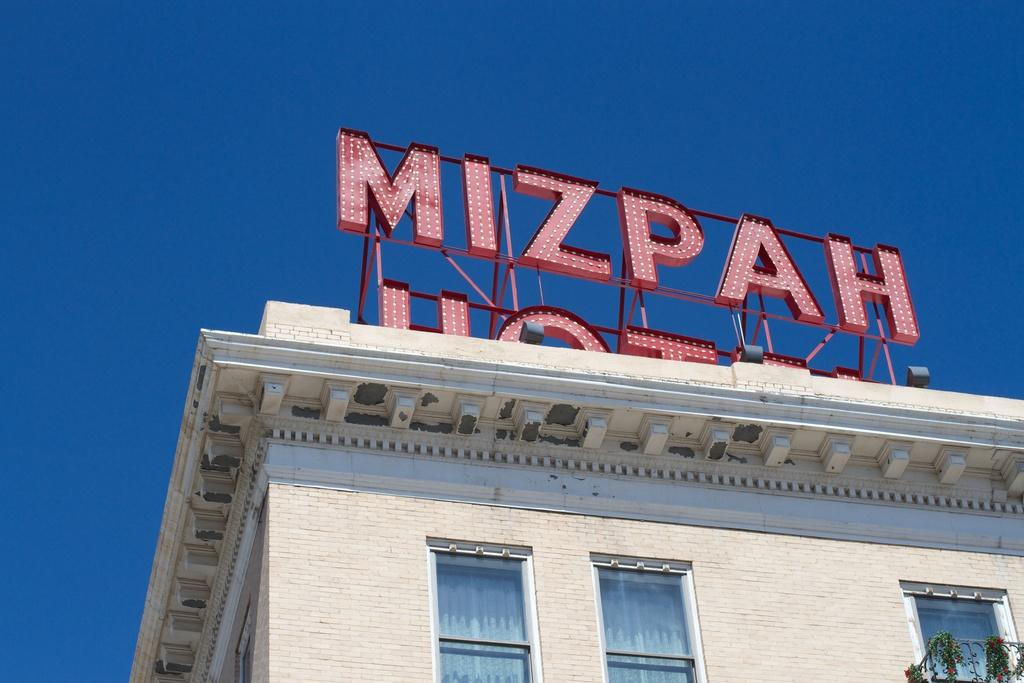What type of structure is in the image? There is a building in the image. What features can be seen on the building? The building has windows and a wall. What type of vegetation is present on the building? Climbing plants are present in the image. What type of flora is visible in the image? Flowers are visible in the image. What type of signage is present on the building? There are naming boards on the building. What can be seen in the background of the image? The sky is visible in the background of the image. How many balloons are tied to the climbing plants in the image? There are no balloons present in the image. 